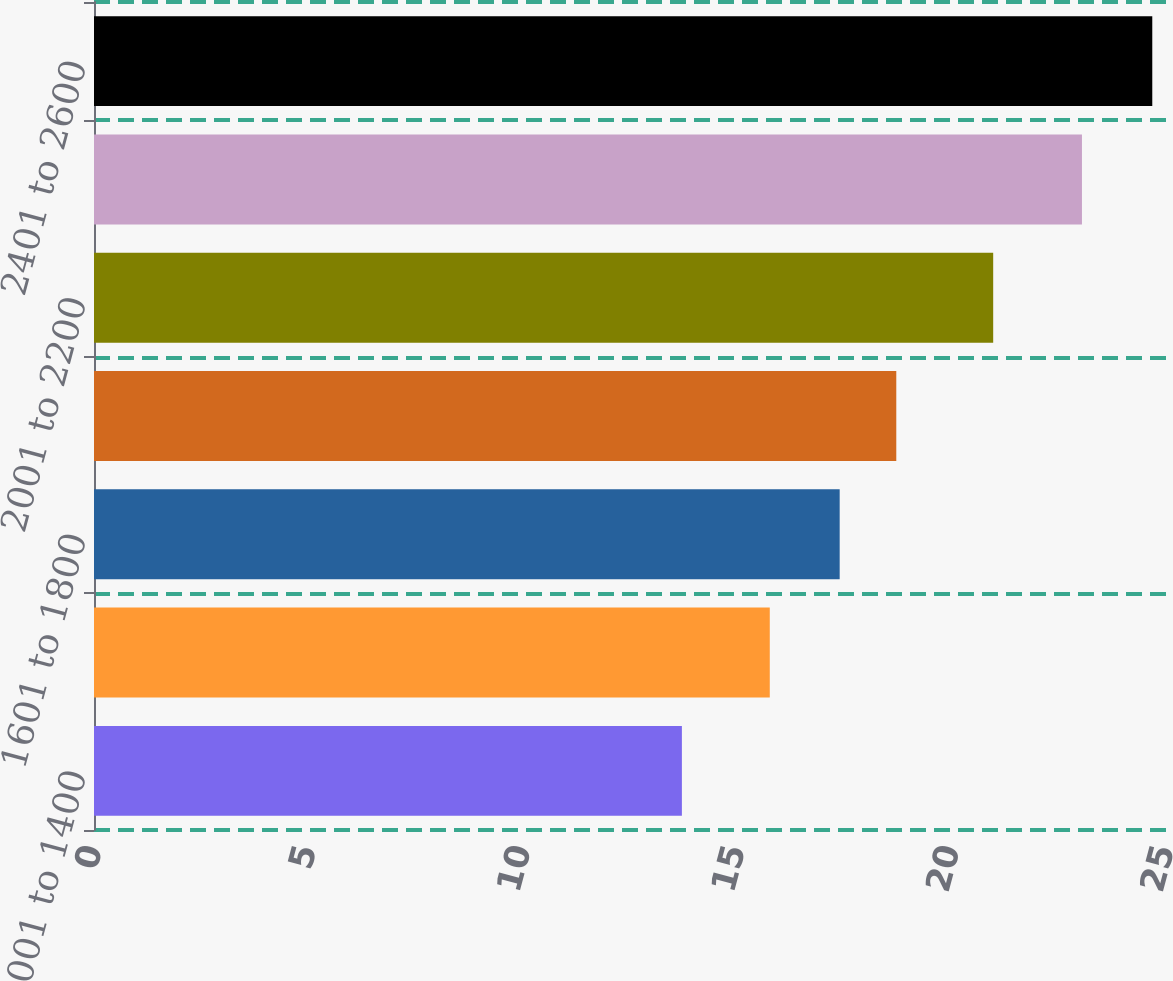Convert chart to OTSL. <chart><loc_0><loc_0><loc_500><loc_500><bar_chart><fcel>001 to 1400<fcel>1401 to 1600<fcel>1601 to 1800<fcel>1801 to 2000<fcel>2001 to 2200<fcel>2201 to 2400<fcel>2401 to 2600<nl><fcel>13.71<fcel>15.76<fcel>17.39<fcel>18.71<fcel>20.97<fcel>23.04<fcel>24.68<nl></chart> 